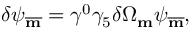<formula> <loc_0><loc_0><loc_500><loc_500>\delta \psi _ { \overline { m } } = \gamma ^ { 0 } \gamma _ { 5 } \delta \Omega _ { m } \psi _ { \overline { m } } ,</formula> 